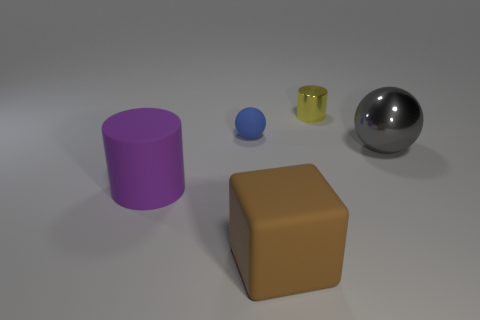Add 2 cylinders. How many objects exist? 7 Subtract all green cylinders. Subtract all gray blocks. How many cylinders are left? 2 Subtract all cylinders. How many objects are left? 3 Subtract all cyan metal objects. Subtract all big matte things. How many objects are left? 3 Add 3 blue rubber spheres. How many blue rubber spheres are left? 4 Add 4 large red matte blocks. How many large red matte blocks exist? 4 Subtract 0 purple balls. How many objects are left? 5 